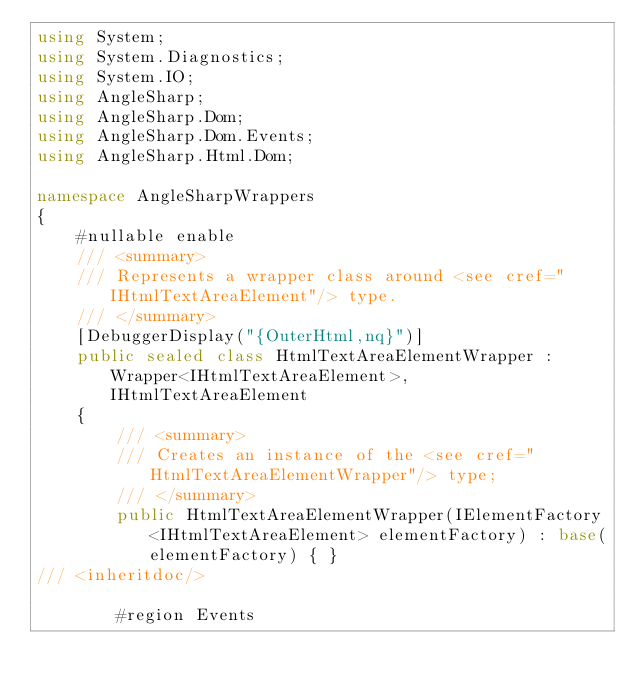<code> <loc_0><loc_0><loc_500><loc_500><_C#_>using System;
using System.Diagnostics;
using System.IO;
using AngleSharp;
using AngleSharp.Dom;
using AngleSharp.Dom.Events;
using AngleSharp.Html.Dom;

namespace AngleSharpWrappers
{
    #nullable enable
    /// <summary>
    /// Represents a wrapper class around <see cref="IHtmlTextAreaElement"/> type.
    /// </summary>
    [DebuggerDisplay("{OuterHtml,nq}")]
    public sealed class HtmlTextAreaElementWrapper : Wrapper<IHtmlTextAreaElement>, IHtmlTextAreaElement
    {
        /// <summary>
        /// Creates an instance of the <see cref="HtmlTextAreaElementWrapper"/> type;
        /// </summary>
        public HtmlTextAreaElementWrapper(IElementFactory<IHtmlTextAreaElement> elementFactory) : base(elementFactory) { }
/// <inheritdoc/>

        #region Events</code> 